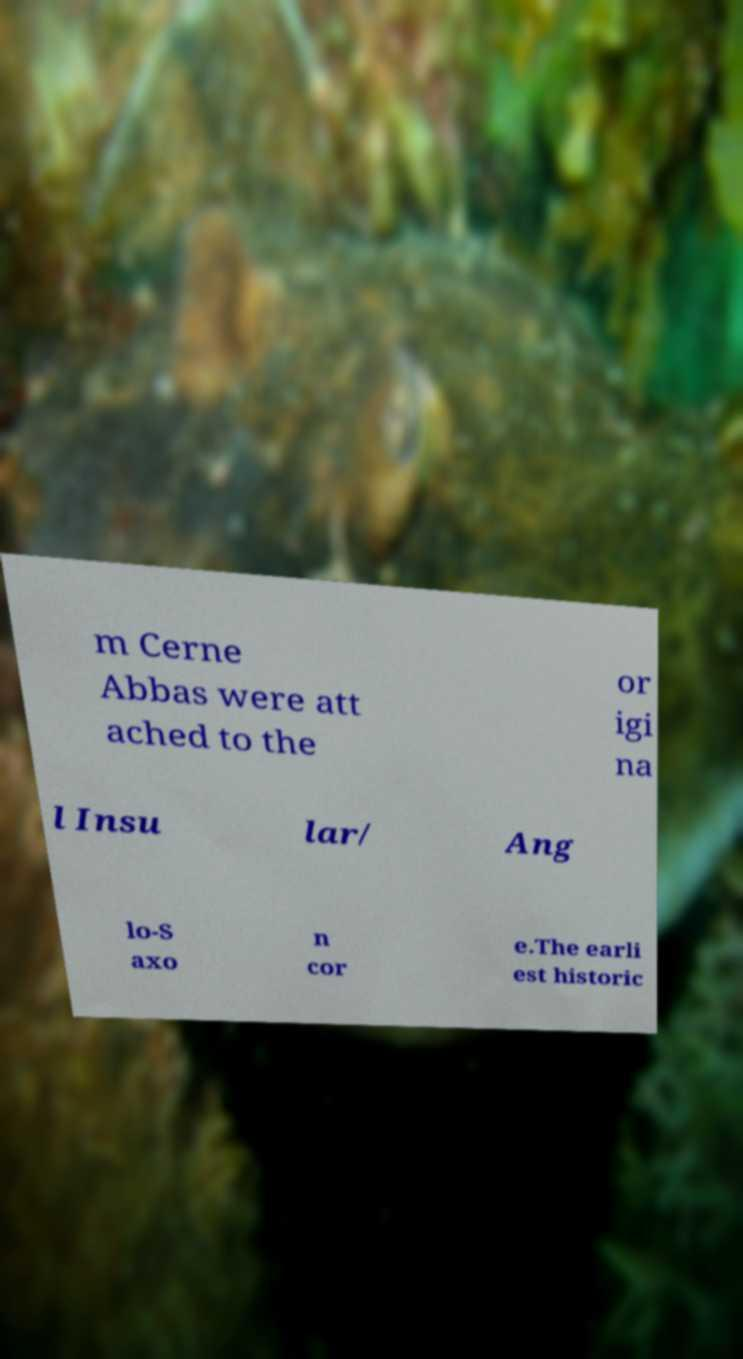Could you assist in decoding the text presented in this image and type it out clearly? m Cerne Abbas were att ached to the or igi na l Insu lar/ Ang lo-S axo n cor e.The earli est historic 